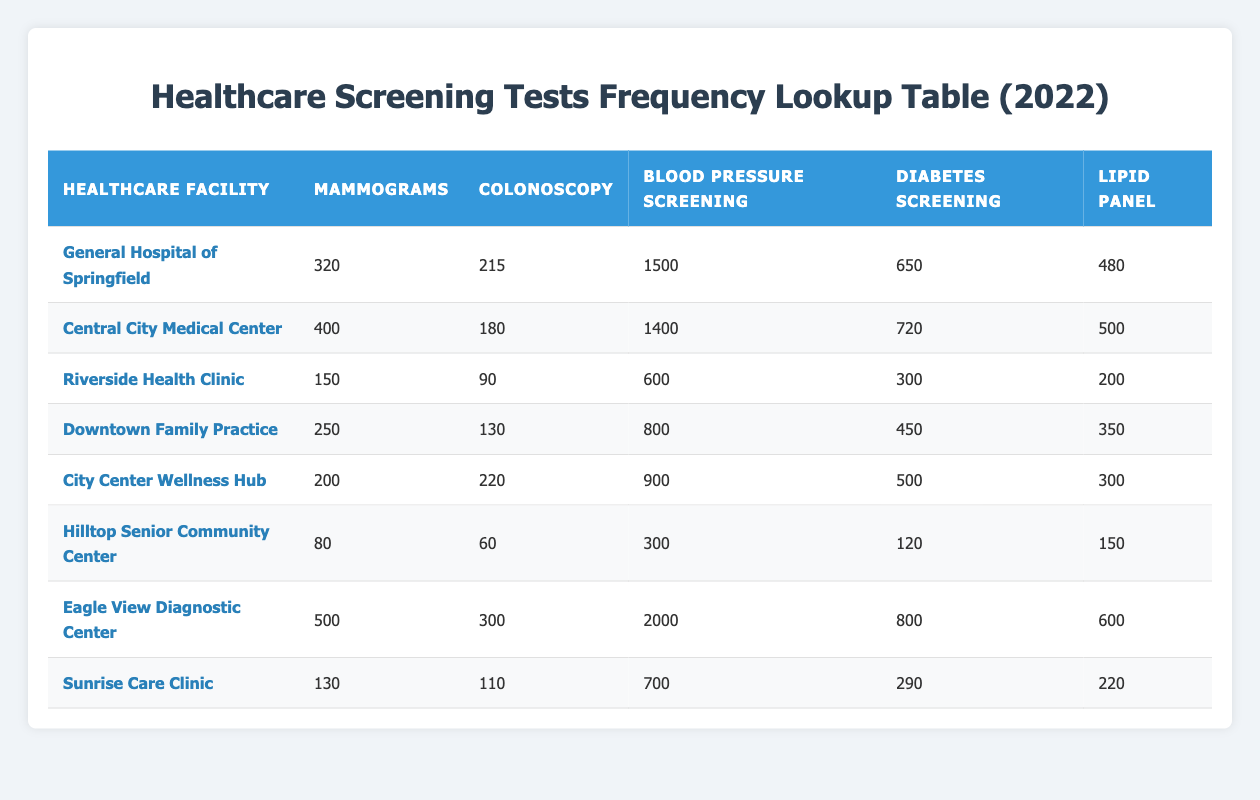What is the total number of Mammograms performed in 2022 across all facilities? To find the total number of Mammograms, add the values from all healthcare facilities: 320 + 400 + 150 + 250 + 200 + 80 + 500 + 130 = 2030.
Answer: 2030 Which facility performed the highest number of Diabetes Screening tests? By looking through the Diabetes Screening column, the highest value is 800 at Eagle View Diagnostic Center.
Answer: Eagle View Diagnostic Center Is there any healthcare facility that performed more than 1000 Blood Pressure screenings? Checking the Blood Pressure Screening column, only Eagle View Diagnostic Center, with a value of 2000, exceeds 1000.
Answer: Yes What is the average number of Colonoscopies performed at the listed facilities? Sum the Colonoscopy values: 215 + 180 + 90 + 130 + 220 + 60 + 300 + 110 = 1095. There are 8 facilities, so the average is 1095 / 8 = 136.875, which can be rounded to 137.
Answer: 137 Which facility had the lowest Lipid Panel screenings, and what was the number? The lowest value in the Lipid Panel column is 150 from Hilltop Senior Community Center.
Answer: Hilltop Senior Community Center, 150 How many more Diabetes screenings did Central City Medical Center perform than Riverside Health Clinic? The Diabetes screenings for Central City Medical Center is 720 and for Riverside Health Clinic is 300. The difference is 720 - 300 = 420.
Answer: 420 What proportion of total Blood Pressure screenings were conducted at Eagle View Diagnostic Center relative to the total? Total Blood Pressure screenings: 1500 + 1400 + 600 + 800 + 900 + 300 + 2000 + 700 = 6300. Eagle View Diagnostic Center conducted 2000. Proportion = 2000 / 6300 ≈ 0.317, or 31.7%.
Answer: 31.7% Is it true that Downtown Family Practice performed more Mammograms than the City Center Wellness Hub? Downtown Family Practice performed 250 Mammograms, while City Center Wellness Hub performed 200 Mammograms, so it is true that Downtown Family Practice performed more.
Answer: Yes 